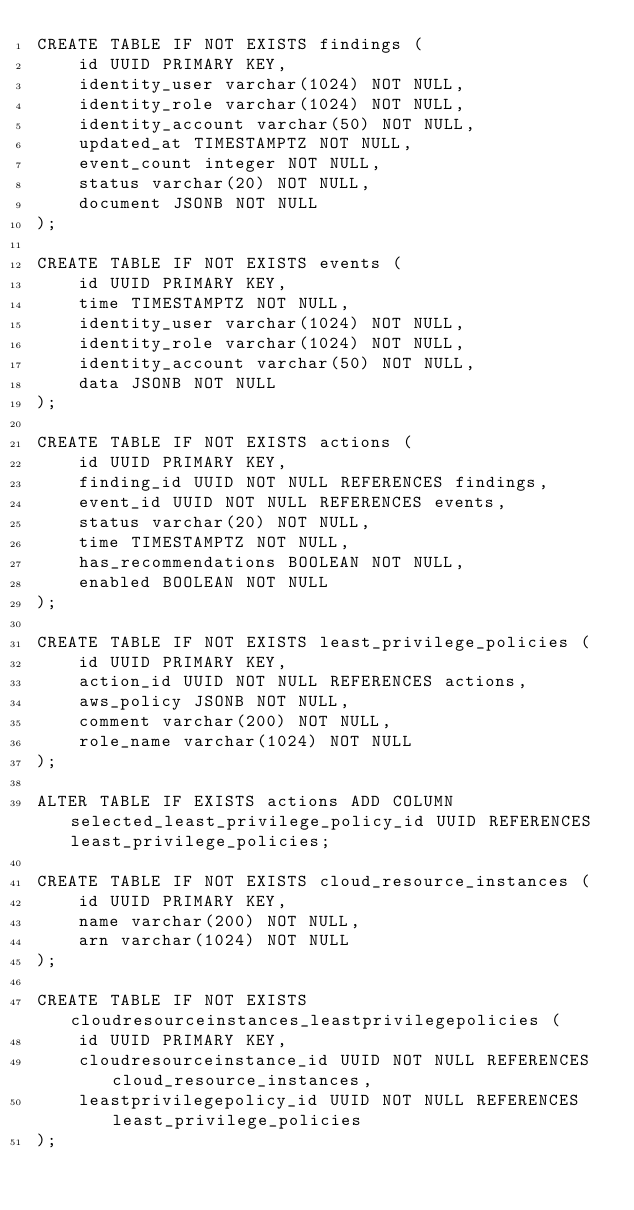<code> <loc_0><loc_0><loc_500><loc_500><_SQL_>CREATE TABLE IF NOT EXISTS findings (
	id UUID PRIMARY KEY,
	identity_user varchar(1024) NOT NULL,
	identity_role varchar(1024) NOT NULL,
	identity_account varchar(50) NOT NULL,
	updated_at TIMESTAMPTZ NOT NULL,
	event_count integer NOT NULL,
	status varchar(20) NOT NULL,
	document JSONB NOT NULL
);

CREATE TABLE IF NOT EXISTS events (
	id UUID PRIMARY KEY,
	time TIMESTAMPTZ NOT NULL,
	identity_user varchar(1024) NOT NULL,
	identity_role varchar(1024) NOT NULL,
	identity_account varchar(50) NOT NULL,
	data JSONB NOT NULL
);

CREATE TABLE IF NOT EXISTS actions (
	id UUID PRIMARY KEY,
	finding_id UUID NOT NULL REFERENCES findings,
	event_id UUID NOT NULL REFERENCES events,
	status varchar(20) NOT NULL,
	time TIMESTAMPTZ NOT NULL,
	has_recommendations BOOLEAN NOT NULL,
	enabled BOOLEAN NOT NULL
);

CREATE TABLE IF NOT EXISTS least_privilege_policies (
	id UUID PRIMARY KEY,
	action_id UUID NOT NULL REFERENCES actions,
	aws_policy JSONB NOT NULL,
	comment varchar(200) NOT NULL,
	role_name varchar(1024) NOT NULL
);

ALTER TABLE IF EXISTS actions ADD COLUMN selected_least_privilege_policy_id UUID REFERENCES least_privilege_policies;

CREATE TABLE IF NOT EXISTS cloud_resource_instances (
	id UUID PRIMARY KEY,
	name varchar(200) NOT NULL,
	arn varchar(1024) NOT NULL
);

CREATE TABLE IF NOT EXISTS cloudresourceinstances_leastprivilegepolicies (
	id UUID PRIMARY KEY,
	cloudresourceinstance_id UUID NOT NULL REFERENCES cloud_resource_instances,
	leastprivilegepolicy_id UUID NOT NULL REFERENCES least_privilege_policies
);</code> 